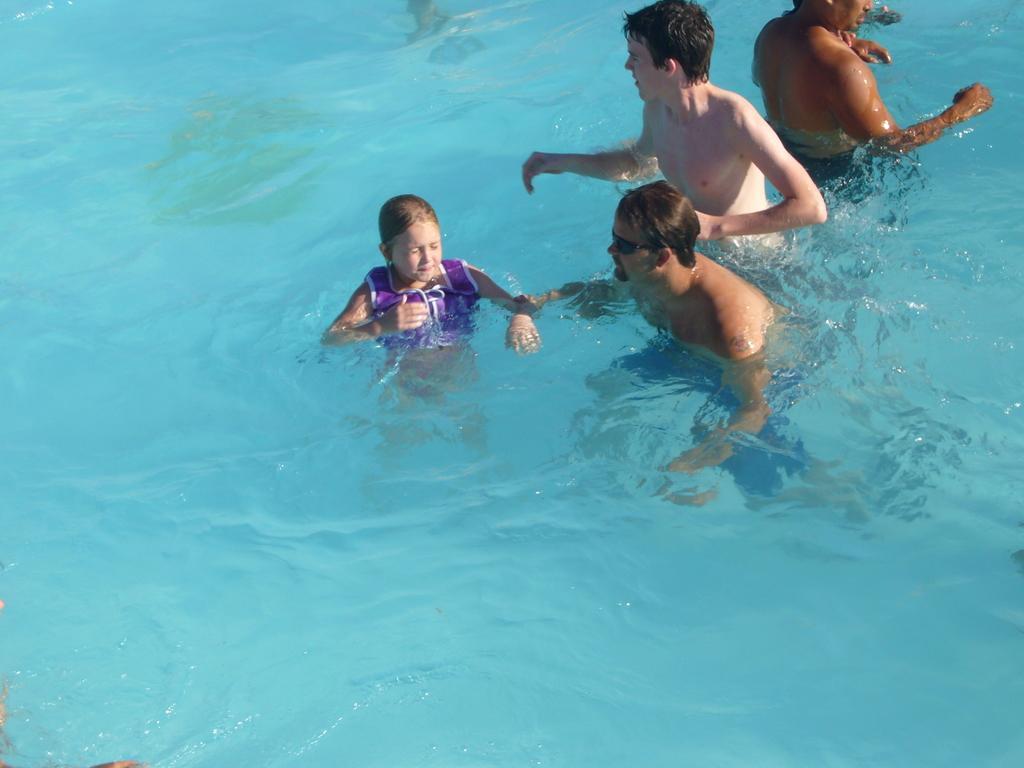Could you give a brief overview of what you see in this image? A girl and three men are in the water. A person is wearing goggles. 